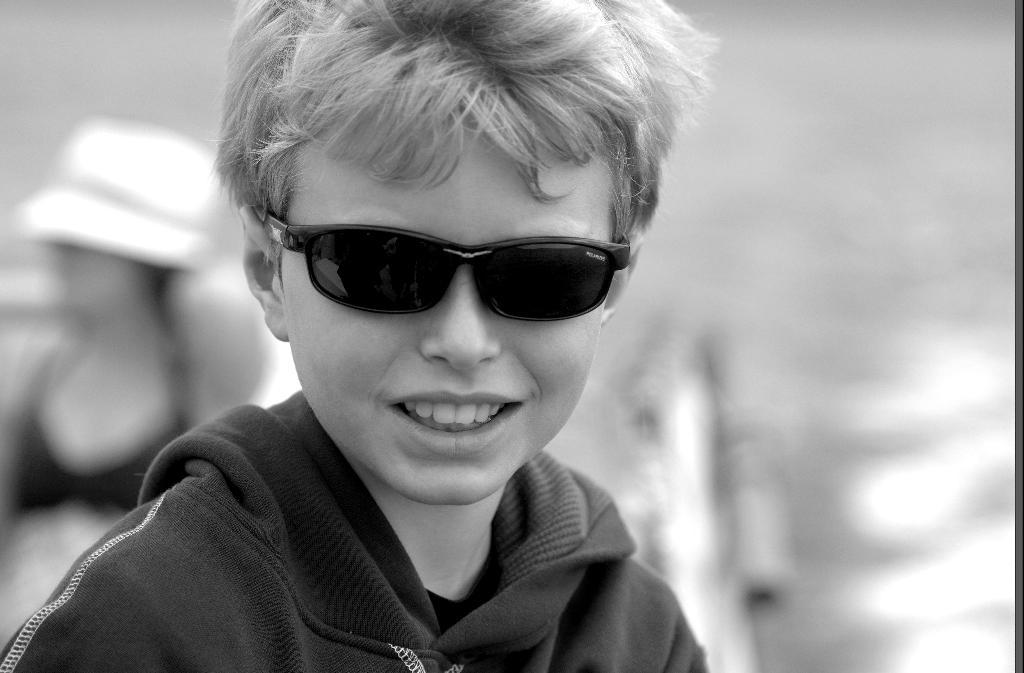What is the color scheme of the image? The image is black and white. Who is present in the image? There is a boy and a woman in the image. What is the boy wearing in the image? The boy is wearing spectacles in the image. What is the woman wearing in the image? The woman is wearing a hat in the image. What flavor of ice cream is the boy holding in the image? There is no ice cream present in the image, and therefore no flavor can be determined. 